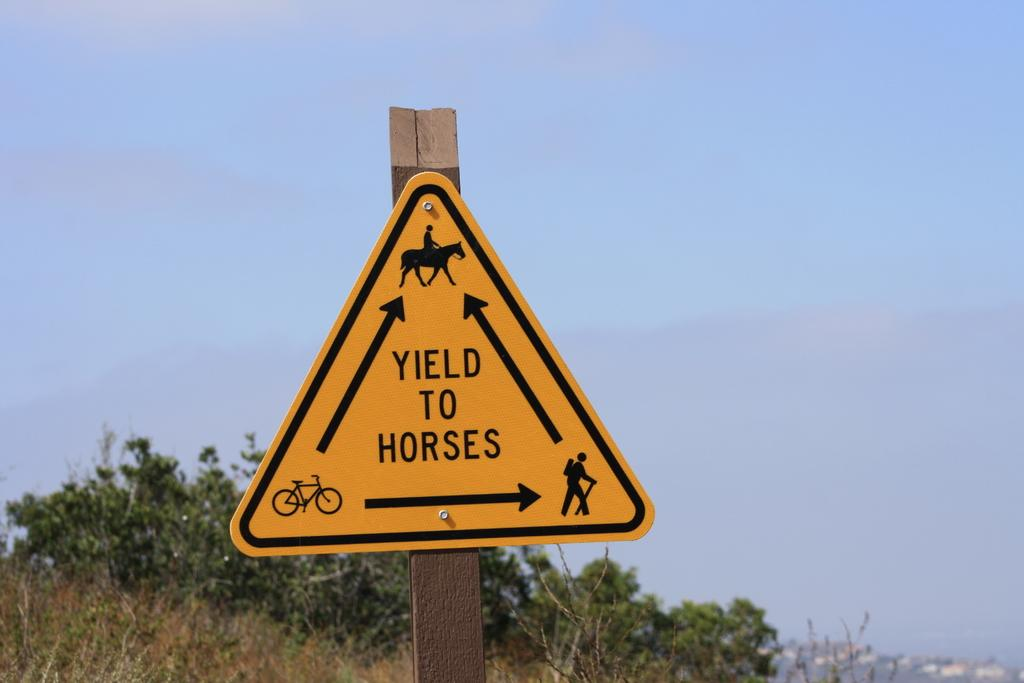<image>
Provide a brief description of the given image. A yellow sign on the road side says "Yield to horses" 